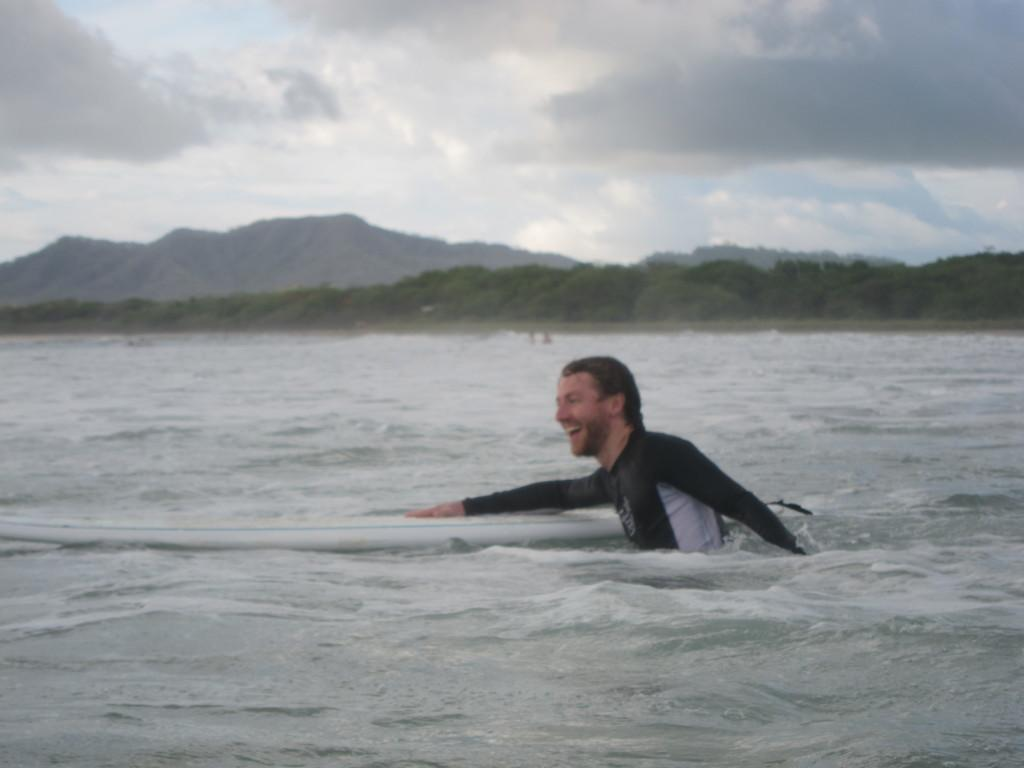What is the person in the image doing? The person is in the water and holding a surfboard. What is the person's expression in the image? The person is smiling. What can be seen in the background of the image? There are trees, hills, and a cloudy sky in the background. What type of apparel is the person wearing for lunch in the image? There is no mention of lunch or apparel in the image; the person is in the water holding a surfboard and smiling. What type of teeth can be seen in the image? There is no indication of teeth in the image, as it features a person in the water holding a surfboard and smiling. 